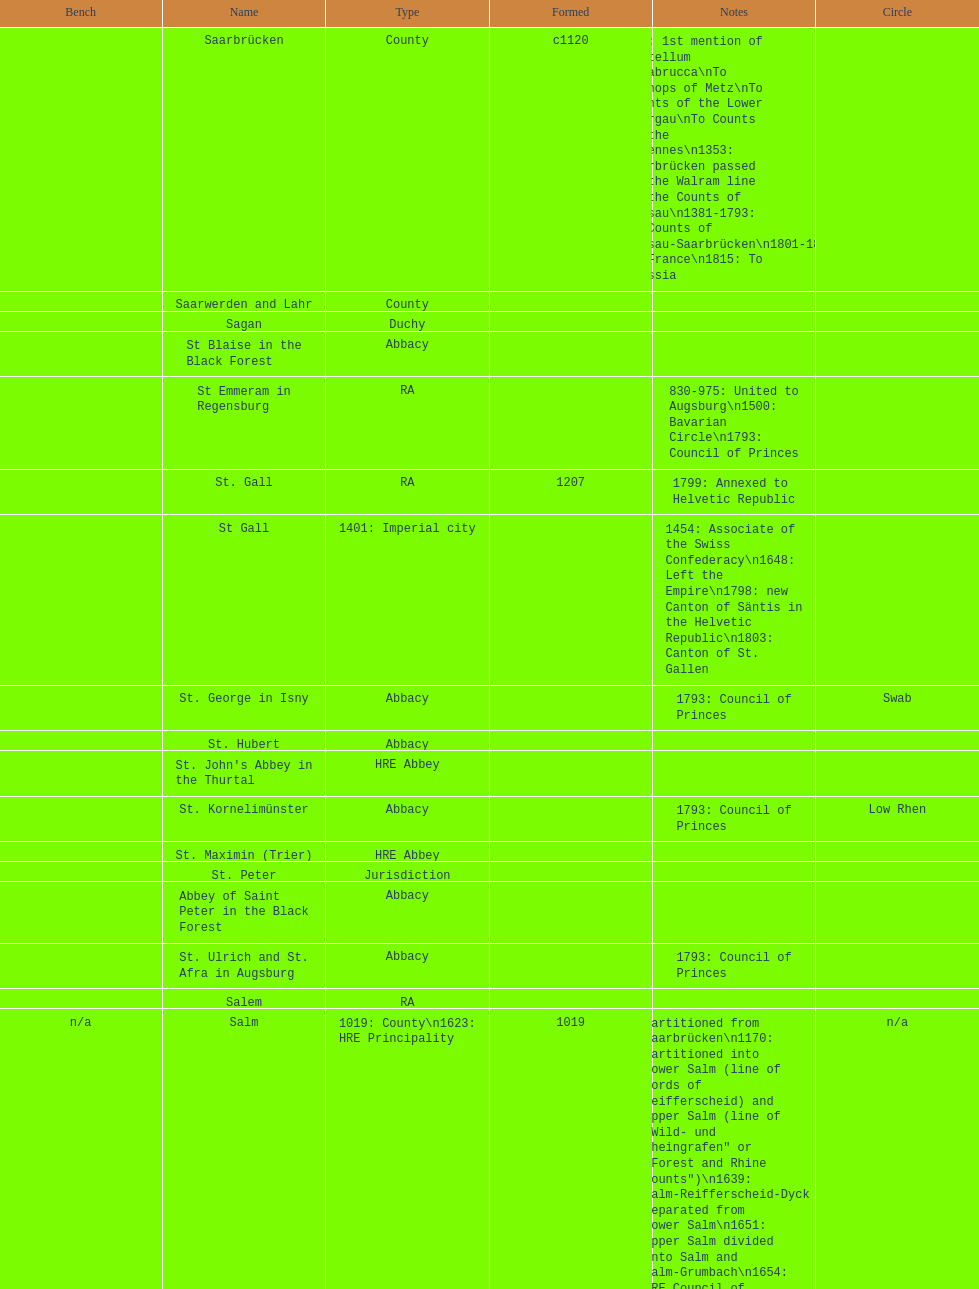Which bench is represented the most? PR. 